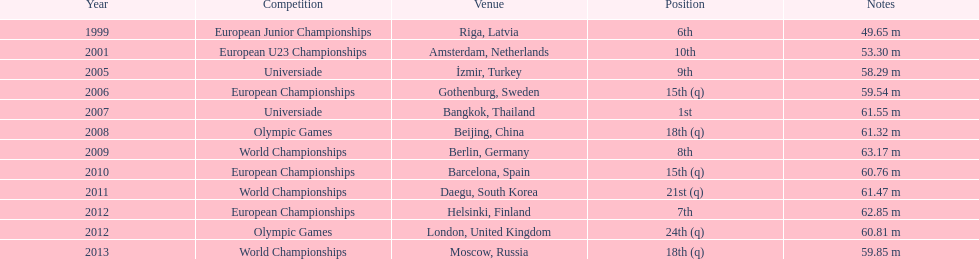Which was the most recent event he competed in before the 2012 olympic games? European Championships. 